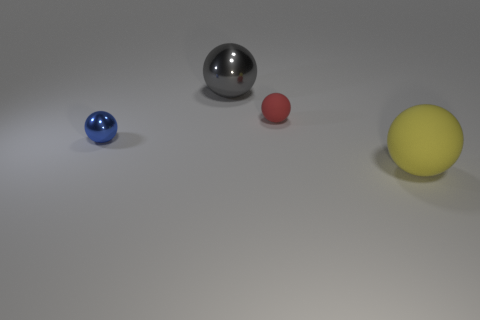Subtract all cyan balls. Subtract all cyan cylinders. How many balls are left? 4 Add 2 tiny spheres. How many objects exist? 6 Subtract all big spheres. Subtract all blue spheres. How many objects are left? 1 Add 3 gray shiny spheres. How many gray shiny spheres are left? 4 Add 3 blue spheres. How many blue spheres exist? 4 Subtract 0 brown cubes. How many objects are left? 4 